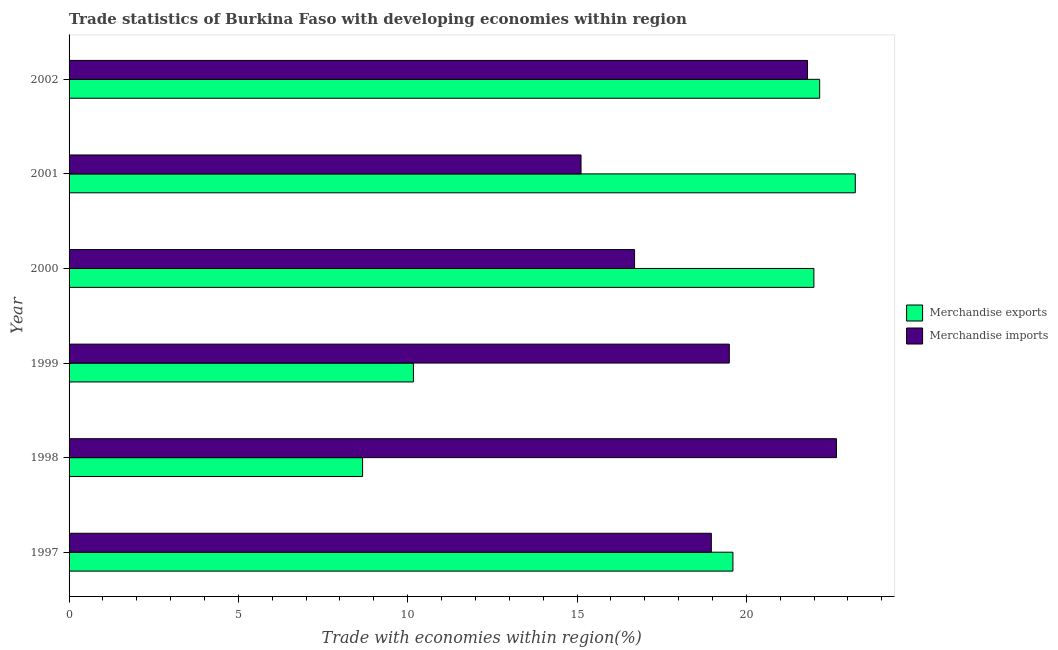How many different coloured bars are there?
Ensure brevity in your answer.  2. Are the number of bars per tick equal to the number of legend labels?
Provide a short and direct response. Yes. Are the number of bars on each tick of the Y-axis equal?
Provide a short and direct response. Yes. How many bars are there on the 2nd tick from the top?
Offer a terse response. 2. What is the label of the 3rd group of bars from the top?
Offer a very short reply. 2000. In how many cases, is the number of bars for a given year not equal to the number of legend labels?
Offer a very short reply. 0. What is the merchandise imports in 1999?
Provide a succinct answer. 19.5. Across all years, what is the maximum merchandise imports?
Keep it short and to the point. 22.66. Across all years, what is the minimum merchandise imports?
Provide a short and direct response. 15.12. In which year was the merchandise exports minimum?
Offer a terse response. 1998. What is the total merchandise imports in the graph?
Provide a succinct answer. 114.75. What is the difference between the merchandise exports in 1997 and that in 1998?
Your answer should be compact. 10.94. What is the difference between the merchandise imports in 2002 and the merchandise exports in 2000?
Ensure brevity in your answer.  -0.19. What is the average merchandise exports per year?
Provide a short and direct response. 17.64. In the year 2000, what is the difference between the merchandise exports and merchandise imports?
Your answer should be compact. 5.3. What is the ratio of the merchandise imports in 1998 to that in 2000?
Give a very brief answer. 1.36. Is the merchandise imports in 2000 less than that in 2002?
Provide a short and direct response. Yes. What is the difference between the highest and the second highest merchandise imports?
Offer a terse response. 0.85. What is the difference between the highest and the lowest merchandise imports?
Provide a short and direct response. 7.54. Is the sum of the merchandise imports in 1999 and 2000 greater than the maximum merchandise exports across all years?
Provide a short and direct response. Yes. What does the 2nd bar from the bottom in 1999 represents?
Your response must be concise. Merchandise imports. How many bars are there?
Your answer should be compact. 12. How many years are there in the graph?
Your answer should be very brief. 6. How many legend labels are there?
Your response must be concise. 2. What is the title of the graph?
Your response must be concise. Trade statistics of Burkina Faso with developing economies within region. Does "Largest city" appear as one of the legend labels in the graph?
Your response must be concise. No. What is the label or title of the X-axis?
Your answer should be very brief. Trade with economies within region(%). What is the Trade with economies within region(%) in Merchandise exports in 1997?
Give a very brief answer. 19.6. What is the Trade with economies within region(%) of Merchandise imports in 1997?
Give a very brief answer. 18.97. What is the Trade with economies within region(%) in Merchandise exports in 1998?
Provide a short and direct response. 8.67. What is the Trade with economies within region(%) in Merchandise imports in 1998?
Ensure brevity in your answer.  22.66. What is the Trade with economies within region(%) in Merchandise exports in 1999?
Offer a very short reply. 10.17. What is the Trade with economies within region(%) of Merchandise imports in 1999?
Ensure brevity in your answer.  19.5. What is the Trade with economies within region(%) of Merchandise exports in 2000?
Your response must be concise. 21.99. What is the Trade with economies within region(%) of Merchandise imports in 2000?
Make the answer very short. 16.7. What is the Trade with economies within region(%) of Merchandise exports in 2001?
Ensure brevity in your answer.  23.22. What is the Trade with economies within region(%) of Merchandise imports in 2001?
Make the answer very short. 15.12. What is the Trade with economies within region(%) of Merchandise exports in 2002?
Provide a short and direct response. 22.17. What is the Trade with economies within region(%) of Merchandise imports in 2002?
Offer a terse response. 21.81. Across all years, what is the maximum Trade with economies within region(%) of Merchandise exports?
Offer a terse response. 23.22. Across all years, what is the maximum Trade with economies within region(%) in Merchandise imports?
Make the answer very short. 22.66. Across all years, what is the minimum Trade with economies within region(%) of Merchandise exports?
Offer a very short reply. 8.67. Across all years, what is the minimum Trade with economies within region(%) of Merchandise imports?
Your response must be concise. 15.12. What is the total Trade with economies within region(%) in Merchandise exports in the graph?
Your answer should be compact. 105.82. What is the total Trade with economies within region(%) in Merchandise imports in the graph?
Provide a short and direct response. 114.75. What is the difference between the Trade with economies within region(%) in Merchandise exports in 1997 and that in 1998?
Your answer should be compact. 10.94. What is the difference between the Trade with economies within region(%) in Merchandise imports in 1997 and that in 1998?
Keep it short and to the point. -3.69. What is the difference between the Trade with economies within region(%) of Merchandise exports in 1997 and that in 1999?
Make the answer very short. 9.43. What is the difference between the Trade with economies within region(%) of Merchandise imports in 1997 and that in 1999?
Keep it short and to the point. -0.53. What is the difference between the Trade with economies within region(%) in Merchandise exports in 1997 and that in 2000?
Keep it short and to the point. -2.39. What is the difference between the Trade with economies within region(%) of Merchandise imports in 1997 and that in 2000?
Offer a terse response. 2.27. What is the difference between the Trade with economies within region(%) of Merchandise exports in 1997 and that in 2001?
Make the answer very short. -3.61. What is the difference between the Trade with economies within region(%) of Merchandise imports in 1997 and that in 2001?
Your response must be concise. 3.85. What is the difference between the Trade with economies within region(%) of Merchandise exports in 1997 and that in 2002?
Provide a succinct answer. -2.56. What is the difference between the Trade with economies within region(%) of Merchandise imports in 1997 and that in 2002?
Your answer should be very brief. -2.84. What is the difference between the Trade with economies within region(%) of Merchandise exports in 1998 and that in 1999?
Provide a short and direct response. -1.5. What is the difference between the Trade with economies within region(%) of Merchandise imports in 1998 and that in 1999?
Provide a short and direct response. 3.16. What is the difference between the Trade with economies within region(%) of Merchandise exports in 1998 and that in 2000?
Provide a succinct answer. -13.33. What is the difference between the Trade with economies within region(%) in Merchandise imports in 1998 and that in 2000?
Make the answer very short. 5.96. What is the difference between the Trade with economies within region(%) of Merchandise exports in 1998 and that in 2001?
Keep it short and to the point. -14.55. What is the difference between the Trade with economies within region(%) of Merchandise imports in 1998 and that in 2001?
Offer a terse response. 7.54. What is the difference between the Trade with economies within region(%) in Merchandise exports in 1998 and that in 2002?
Give a very brief answer. -13.5. What is the difference between the Trade with economies within region(%) in Merchandise imports in 1998 and that in 2002?
Provide a succinct answer. 0.85. What is the difference between the Trade with economies within region(%) of Merchandise exports in 1999 and that in 2000?
Make the answer very short. -11.83. What is the difference between the Trade with economies within region(%) in Merchandise imports in 1999 and that in 2000?
Your response must be concise. 2.8. What is the difference between the Trade with economies within region(%) of Merchandise exports in 1999 and that in 2001?
Give a very brief answer. -13.05. What is the difference between the Trade with economies within region(%) in Merchandise imports in 1999 and that in 2001?
Offer a terse response. 4.38. What is the difference between the Trade with economies within region(%) in Merchandise exports in 1999 and that in 2002?
Keep it short and to the point. -12. What is the difference between the Trade with economies within region(%) in Merchandise imports in 1999 and that in 2002?
Your response must be concise. -2.31. What is the difference between the Trade with economies within region(%) of Merchandise exports in 2000 and that in 2001?
Offer a terse response. -1.22. What is the difference between the Trade with economies within region(%) in Merchandise imports in 2000 and that in 2001?
Your answer should be very brief. 1.58. What is the difference between the Trade with economies within region(%) in Merchandise exports in 2000 and that in 2002?
Your answer should be compact. -0.17. What is the difference between the Trade with economies within region(%) of Merchandise imports in 2000 and that in 2002?
Offer a terse response. -5.11. What is the difference between the Trade with economies within region(%) in Merchandise exports in 2001 and that in 2002?
Give a very brief answer. 1.05. What is the difference between the Trade with economies within region(%) in Merchandise imports in 2001 and that in 2002?
Your answer should be compact. -6.69. What is the difference between the Trade with economies within region(%) of Merchandise exports in 1997 and the Trade with economies within region(%) of Merchandise imports in 1998?
Make the answer very short. -3.06. What is the difference between the Trade with economies within region(%) in Merchandise exports in 1997 and the Trade with economies within region(%) in Merchandise imports in 1999?
Offer a very short reply. 0.11. What is the difference between the Trade with economies within region(%) of Merchandise exports in 1997 and the Trade with economies within region(%) of Merchandise imports in 2000?
Offer a terse response. 2.9. What is the difference between the Trade with economies within region(%) in Merchandise exports in 1997 and the Trade with economies within region(%) in Merchandise imports in 2001?
Your answer should be very brief. 4.49. What is the difference between the Trade with economies within region(%) in Merchandise exports in 1997 and the Trade with economies within region(%) in Merchandise imports in 2002?
Your response must be concise. -2.2. What is the difference between the Trade with economies within region(%) in Merchandise exports in 1998 and the Trade with economies within region(%) in Merchandise imports in 1999?
Your answer should be very brief. -10.83. What is the difference between the Trade with economies within region(%) of Merchandise exports in 1998 and the Trade with economies within region(%) of Merchandise imports in 2000?
Offer a terse response. -8.03. What is the difference between the Trade with economies within region(%) in Merchandise exports in 1998 and the Trade with economies within region(%) in Merchandise imports in 2001?
Ensure brevity in your answer.  -6.45. What is the difference between the Trade with economies within region(%) of Merchandise exports in 1998 and the Trade with economies within region(%) of Merchandise imports in 2002?
Keep it short and to the point. -13.14. What is the difference between the Trade with economies within region(%) of Merchandise exports in 1999 and the Trade with economies within region(%) of Merchandise imports in 2000?
Offer a very short reply. -6.53. What is the difference between the Trade with economies within region(%) of Merchandise exports in 1999 and the Trade with economies within region(%) of Merchandise imports in 2001?
Provide a short and direct response. -4.95. What is the difference between the Trade with economies within region(%) in Merchandise exports in 1999 and the Trade with economies within region(%) in Merchandise imports in 2002?
Ensure brevity in your answer.  -11.64. What is the difference between the Trade with economies within region(%) in Merchandise exports in 2000 and the Trade with economies within region(%) in Merchandise imports in 2001?
Provide a short and direct response. 6.88. What is the difference between the Trade with economies within region(%) in Merchandise exports in 2000 and the Trade with economies within region(%) in Merchandise imports in 2002?
Offer a very short reply. 0.19. What is the difference between the Trade with economies within region(%) in Merchandise exports in 2001 and the Trade with economies within region(%) in Merchandise imports in 2002?
Your response must be concise. 1.41. What is the average Trade with economies within region(%) in Merchandise exports per year?
Your answer should be very brief. 17.64. What is the average Trade with economies within region(%) of Merchandise imports per year?
Your response must be concise. 19.12. In the year 1997, what is the difference between the Trade with economies within region(%) of Merchandise exports and Trade with economies within region(%) of Merchandise imports?
Your answer should be very brief. 0.64. In the year 1998, what is the difference between the Trade with economies within region(%) in Merchandise exports and Trade with economies within region(%) in Merchandise imports?
Your response must be concise. -13.99. In the year 1999, what is the difference between the Trade with economies within region(%) of Merchandise exports and Trade with economies within region(%) of Merchandise imports?
Give a very brief answer. -9.33. In the year 2000, what is the difference between the Trade with economies within region(%) of Merchandise exports and Trade with economies within region(%) of Merchandise imports?
Offer a terse response. 5.3. In the year 2001, what is the difference between the Trade with economies within region(%) of Merchandise exports and Trade with economies within region(%) of Merchandise imports?
Your answer should be very brief. 8.1. In the year 2002, what is the difference between the Trade with economies within region(%) in Merchandise exports and Trade with economies within region(%) in Merchandise imports?
Ensure brevity in your answer.  0.36. What is the ratio of the Trade with economies within region(%) in Merchandise exports in 1997 to that in 1998?
Your response must be concise. 2.26. What is the ratio of the Trade with economies within region(%) of Merchandise imports in 1997 to that in 1998?
Provide a short and direct response. 0.84. What is the ratio of the Trade with economies within region(%) of Merchandise exports in 1997 to that in 1999?
Your answer should be very brief. 1.93. What is the ratio of the Trade with economies within region(%) in Merchandise imports in 1997 to that in 1999?
Keep it short and to the point. 0.97. What is the ratio of the Trade with economies within region(%) in Merchandise exports in 1997 to that in 2000?
Offer a terse response. 0.89. What is the ratio of the Trade with economies within region(%) of Merchandise imports in 1997 to that in 2000?
Your answer should be very brief. 1.14. What is the ratio of the Trade with economies within region(%) in Merchandise exports in 1997 to that in 2001?
Offer a terse response. 0.84. What is the ratio of the Trade with economies within region(%) of Merchandise imports in 1997 to that in 2001?
Provide a short and direct response. 1.25. What is the ratio of the Trade with economies within region(%) of Merchandise exports in 1997 to that in 2002?
Your answer should be very brief. 0.88. What is the ratio of the Trade with economies within region(%) of Merchandise imports in 1997 to that in 2002?
Your response must be concise. 0.87. What is the ratio of the Trade with economies within region(%) in Merchandise exports in 1998 to that in 1999?
Ensure brevity in your answer.  0.85. What is the ratio of the Trade with economies within region(%) in Merchandise imports in 1998 to that in 1999?
Give a very brief answer. 1.16. What is the ratio of the Trade with economies within region(%) in Merchandise exports in 1998 to that in 2000?
Provide a short and direct response. 0.39. What is the ratio of the Trade with economies within region(%) in Merchandise imports in 1998 to that in 2000?
Your answer should be compact. 1.36. What is the ratio of the Trade with economies within region(%) of Merchandise exports in 1998 to that in 2001?
Offer a very short reply. 0.37. What is the ratio of the Trade with economies within region(%) in Merchandise imports in 1998 to that in 2001?
Keep it short and to the point. 1.5. What is the ratio of the Trade with economies within region(%) of Merchandise exports in 1998 to that in 2002?
Your answer should be compact. 0.39. What is the ratio of the Trade with economies within region(%) in Merchandise imports in 1998 to that in 2002?
Keep it short and to the point. 1.04. What is the ratio of the Trade with economies within region(%) of Merchandise exports in 1999 to that in 2000?
Your answer should be very brief. 0.46. What is the ratio of the Trade with economies within region(%) in Merchandise imports in 1999 to that in 2000?
Offer a terse response. 1.17. What is the ratio of the Trade with economies within region(%) in Merchandise exports in 1999 to that in 2001?
Your answer should be very brief. 0.44. What is the ratio of the Trade with economies within region(%) of Merchandise imports in 1999 to that in 2001?
Make the answer very short. 1.29. What is the ratio of the Trade with economies within region(%) of Merchandise exports in 1999 to that in 2002?
Your answer should be very brief. 0.46. What is the ratio of the Trade with economies within region(%) in Merchandise imports in 1999 to that in 2002?
Keep it short and to the point. 0.89. What is the ratio of the Trade with economies within region(%) in Merchandise exports in 2000 to that in 2001?
Ensure brevity in your answer.  0.95. What is the ratio of the Trade with economies within region(%) in Merchandise imports in 2000 to that in 2001?
Your response must be concise. 1.1. What is the ratio of the Trade with economies within region(%) in Merchandise exports in 2000 to that in 2002?
Make the answer very short. 0.99. What is the ratio of the Trade with economies within region(%) in Merchandise imports in 2000 to that in 2002?
Give a very brief answer. 0.77. What is the ratio of the Trade with economies within region(%) in Merchandise exports in 2001 to that in 2002?
Your answer should be very brief. 1.05. What is the ratio of the Trade with economies within region(%) of Merchandise imports in 2001 to that in 2002?
Your response must be concise. 0.69. What is the difference between the highest and the second highest Trade with economies within region(%) in Merchandise exports?
Your answer should be compact. 1.05. What is the difference between the highest and the second highest Trade with economies within region(%) of Merchandise imports?
Provide a succinct answer. 0.85. What is the difference between the highest and the lowest Trade with economies within region(%) of Merchandise exports?
Give a very brief answer. 14.55. What is the difference between the highest and the lowest Trade with economies within region(%) of Merchandise imports?
Provide a succinct answer. 7.54. 